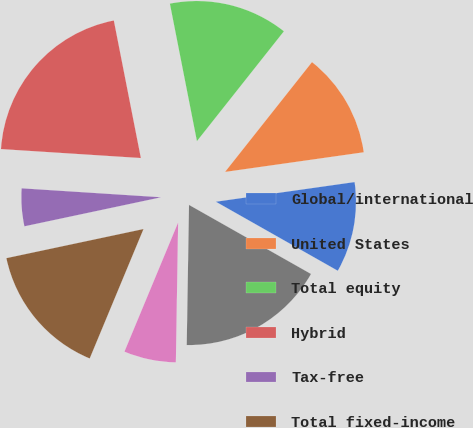<chart> <loc_0><loc_0><loc_500><loc_500><pie_chart><fcel>Global/international<fcel>United States<fcel>Total equity<fcel>Hybrid<fcel>Tax-free<fcel>Total fixed-income<fcel>Cash Management<fcel>Total<nl><fcel>10.44%<fcel>12.1%<fcel>13.75%<fcel>20.89%<fcel>4.35%<fcel>15.4%<fcel>6.01%<fcel>17.06%<nl></chart> 